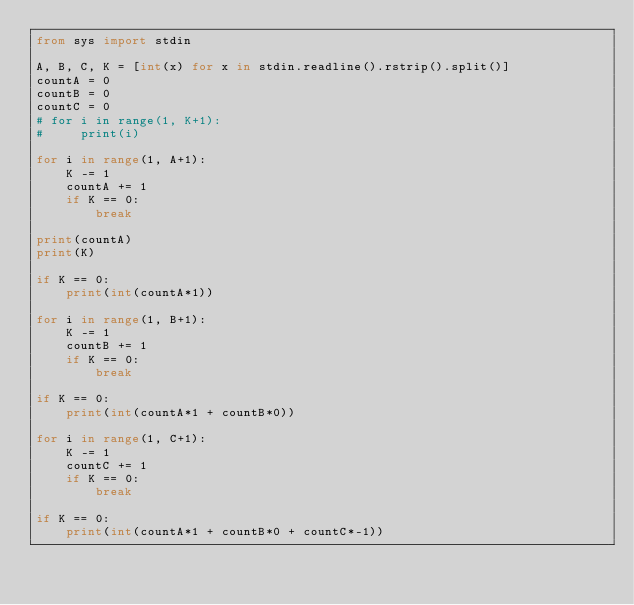Convert code to text. <code><loc_0><loc_0><loc_500><loc_500><_Python_>from sys import stdin

A, B, C, K = [int(x) for x in stdin.readline().rstrip().split()]
countA = 0
countB = 0
countC = 0
# for i in range(1, K+1):
#     print(i)

for i in range(1, A+1):
    K -= 1
    countA += 1
    if K == 0:
        break

print(countA)
print(K)

if K == 0:
    print(int(countA*1))

for i in range(1, B+1):
    K -= 1
    countB += 1
    if K == 0:
        break

if K == 0:
    print(int(countA*1 + countB*0))

for i in range(1, C+1):
    K -= 1
    countC += 1
    if K == 0:
        break

if K == 0:
    print(int(countA*1 + countB*0 + countC*-1))
</code> 